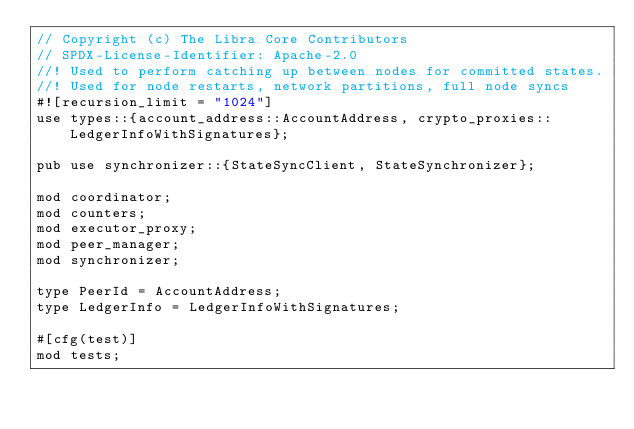Convert code to text. <code><loc_0><loc_0><loc_500><loc_500><_Rust_>// Copyright (c) The Libra Core Contributors
// SPDX-License-Identifier: Apache-2.0
//! Used to perform catching up between nodes for committed states.
//! Used for node restarts, network partitions, full node syncs
#![recursion_limit = "1024"]
use types::{account_address::AccountAddress, crypto_proxies::LedgerInfoWithSignatures};

pub use synchronizer::{StateSyncClient, StateSynchronizer};

mod coordinator;
mod counters;
mod executor_proxy;
mod peer_manager;
mod synchronizer;

type PeerId = AccountAddress;
type LedgerInfo = LedgerInfoWithSignatures;

#[cfg(test)]
mod tests;
</code> 